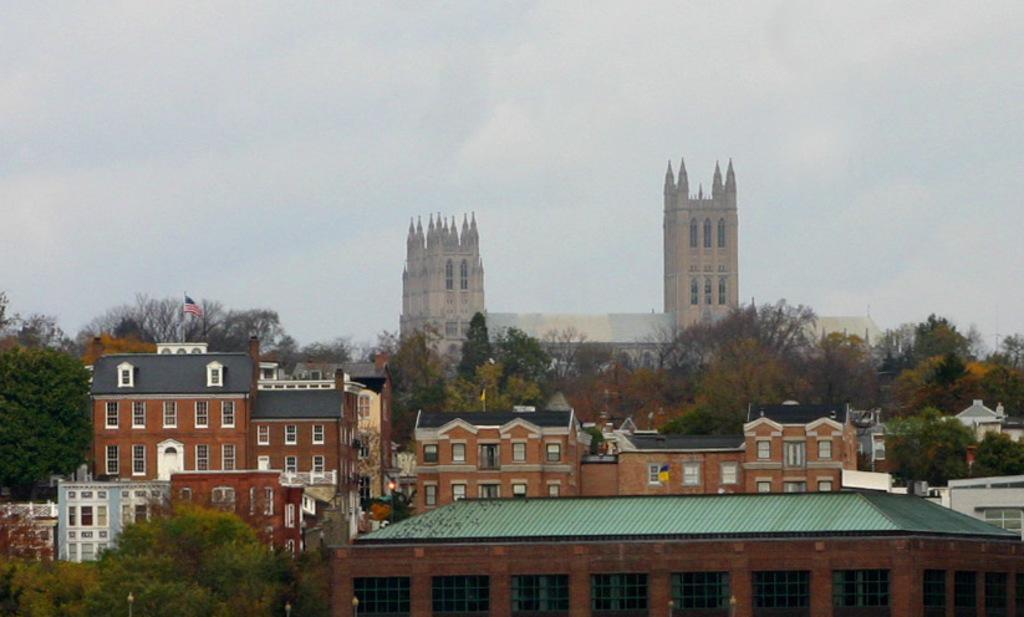How would you summarize this image in a sentence or two? In this image I can see few buildings in brown and white color and I can see trees in green color. Background I can see a flag in blue, white and red color and the sky is in white color. 